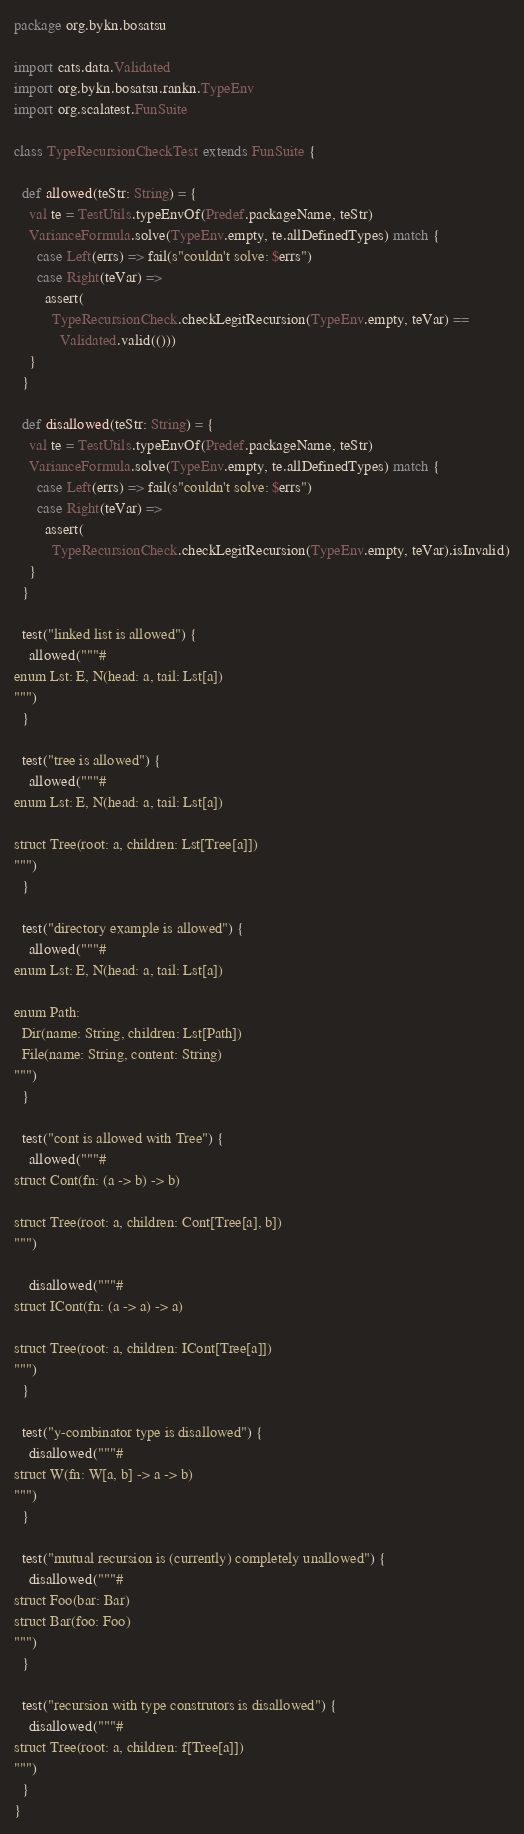Convert code to text. <code><loc_0><loc_0><loc_500><loc_500><_Scala_>package org.bykn.bosatsu

import cats.data.Validated
import org.bykn.bosatsu.rankn.TypeEnv
import org.scalatest.FunSuite

class TypeRecursionCheckTest extends FunSuite {

  def allowed(teStr: String) = {
    val te = TestUtils.typeEnvOf(Predef.packageName, teStr)
    VarianceFormula.solve(TypeEnv.empty, te.allDefinedTypes) match {
      case Left(errs) => fail(s"couldn't solve: $errs")
      case Right(teVar) =>
        assert(
          TypeRecursionCheck.checkLegitRecursion(TypeEnv.empty, teVar) ==
            Validated.valid(()))
    }
  }

  def disallowed(teStr: String) = {
    val te = TestUtils.typeEnvOf(Predef.packageName, teStr)
    VarianceFormula.solve(TypeEnv.empty, te.allDefinedTypes) match {
      case Left(errs) => fail(s"couldn't solve: $errs")
      case Right(teVar) =>
        assert(
          TypeRecursionCheck.checkLegitRecursion(TypeEnv.empty, teVar).isInvalid)
    }
  }

  test("linked list is allowed") {
    allowed("""#
enum Lst: E, N(head: a, tail: Lst[a])
""")
  }

  test("tree is allowed") {
    allowed("""#
enum Lst: E, N(head: a, tail: Lst[a])

struct Tree(root: a, children: Lst[Tree[a]])
""")
  }

  test("directory example is allowed") {
    allowed("""#
enum Lst: E, N(head: a, tail: Lst[a])

enum Path:
  Dir(name: String, children: Lst[Path])
  File(name: String, content: String)
""")
  }

  test("cont is allowed with Tree") {
    allowed("""#
struct Cont(fn: (a -> b) -> b)

struct Tree(root: a, children: Cont[Tree[a], b])
""")

    disallowed("""#
struct ICont(fn: (a -> a) -> a)

struct Tree(root: a, children: ICont[Tree[a]])
""")
  }

  test("y-combinator type is disallowed") {
    disallowed("""#
struct W(fn: W[a, b] -> a -> b)
""")
  }

  test("mutual recursion is (currently) completely unallowed") {
    disallowed("""#
struct Foo(bar: Bar)
struct Bar(foo: Foo)
""")
  }

  test("recursion with type construtors is disallowed") {
    disallowed("""#
struct Tree(root: a, children: f[Tree[a]])
""")
  }
}
</code> 